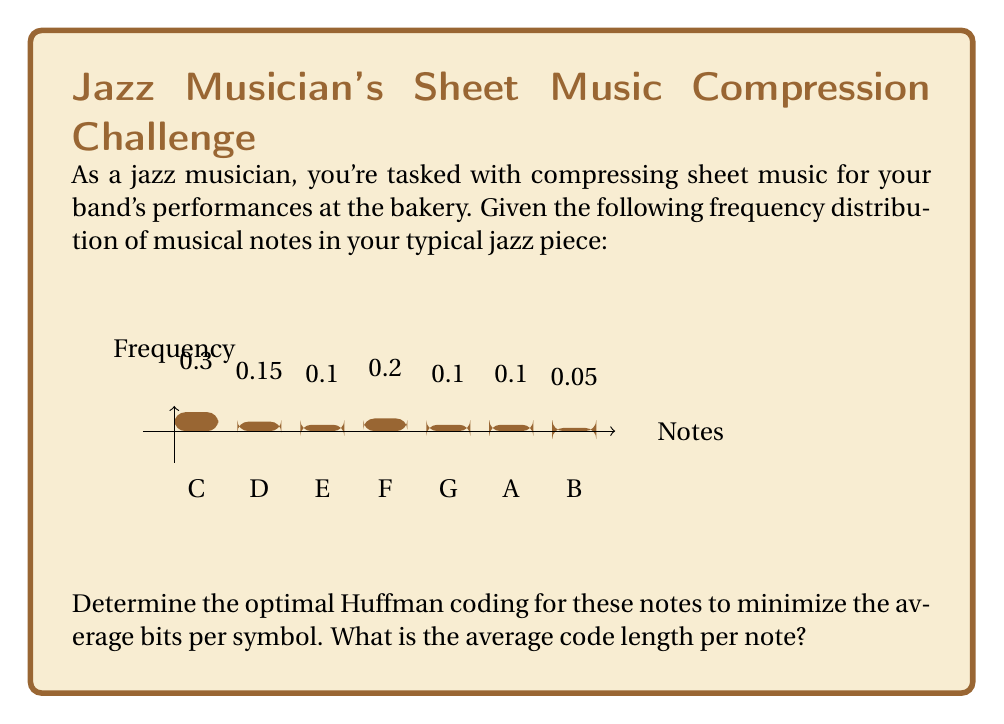Could you help me with this problem? To solve this problem, we'll use Huffman coding to create an optimal prefix code. Here's the step-by-step process:

1) First, we'll arrange the notes in descending order of frequency:
   C (0.3), F (0.2), D (0.15), E (0.1), G (0.1), A (0.1), B (0.05)

2) We'll build the Huffman tree from bottom up:
   - Combine B (0.05) and A (0.1) to form a node with probability 0.15
   - Combine this new node (0.15) with G (0.1) to form a node with probability 0.25
   - Combine E (0.1) and D (0.15) to form a node with probability 0.25
   - Combine the two 0.25 nodes to form a node with probability 0.5
   - Combine F (0.2) with the 0.5 node to form a node with probability 0.7
   - Finally, combine C (0.3) with the 0.7 node to complete the tree

3) Now we can assign codes (0 for left branches, 1 for right branches):
   C: 0
   F: 10
   D: 1100
   E: 1101
   G: 1110
   A: 11110
   B: 11111

4) To calculate the average code length, we multiply each note's frequency by its code length and sum:

   $$L_{avg} = 0.3(1) + 0.2(2) + 0.15(4) + 0.1(4) + 0.1(4) + 0.1(5) + 0.05(5)$$
   $$L_{avg} = 0.3 + 0.4 + 0.6 + 0.4 + 0.4 + 0.5 + 0.25$$
   $$L_{avg} = 2.85\text{ bits}$$

Therefore, the average code length per note is 2.85 bits.
Answer: 2.85 bits 